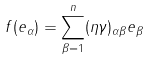Convert formula to latex. <formula><loc_0><loc_0><loc_500><loc_500>f ( e _ { \alpha } ) = \sum ^ { n } _ { \beta = 1 } ( \eta \gamma ) _ { \alpha \beta } e _ { \beta }</formula> 